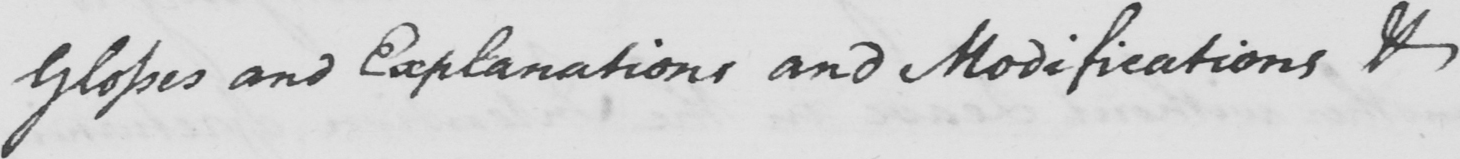What does this handwritten line say? Glosses and Explanations and Modifications & 